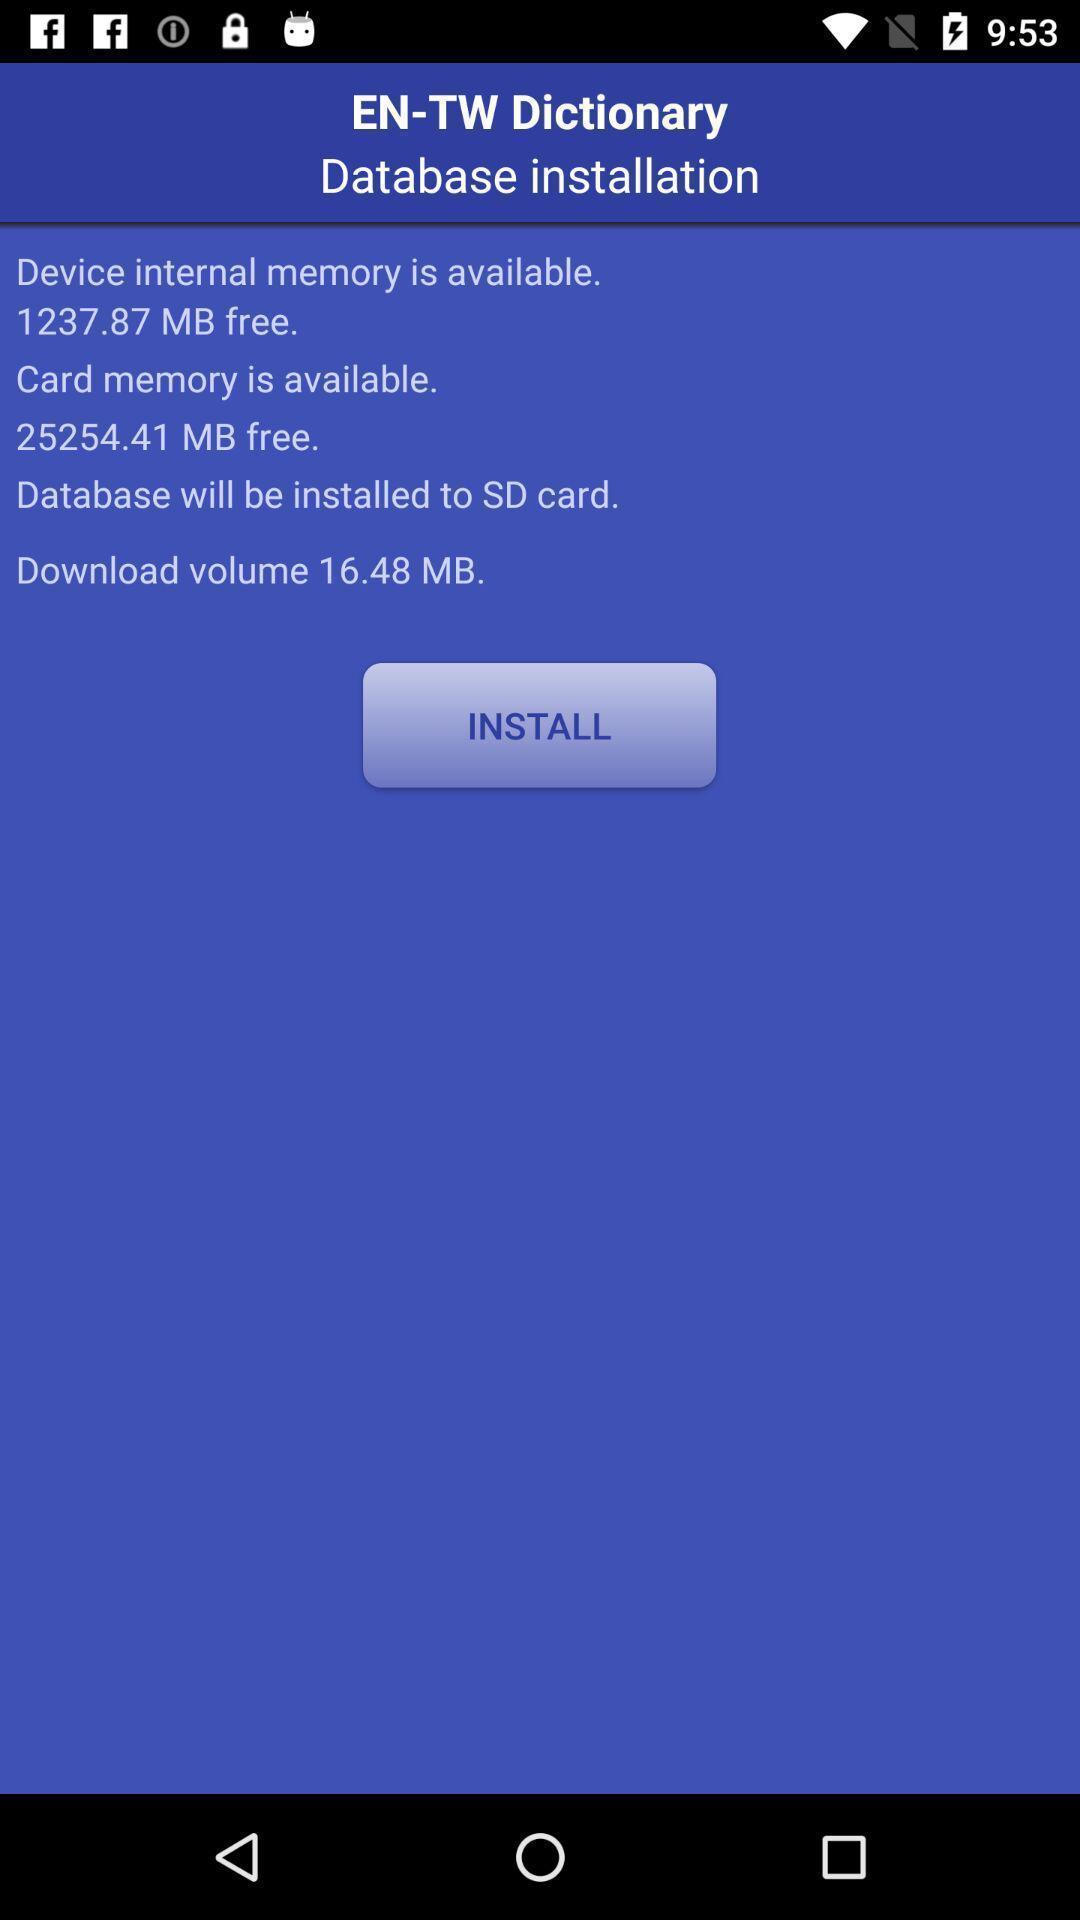What details can you identify in this image? Screen displaying the install option. 